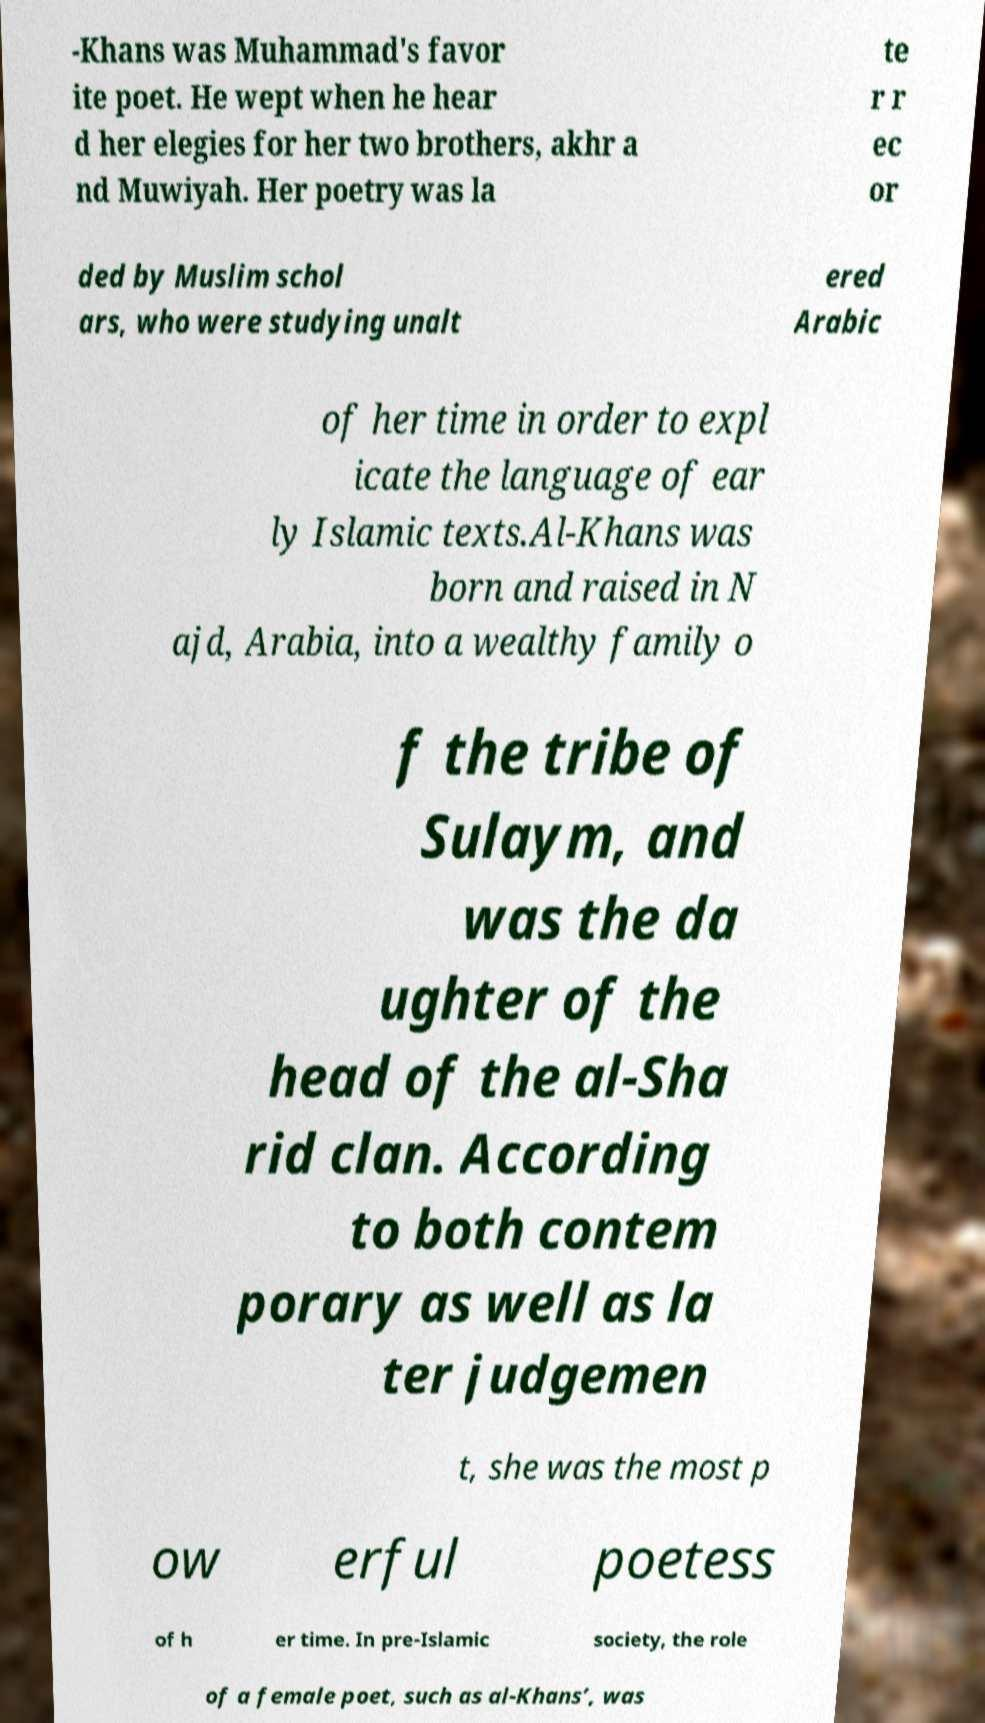Please identify and transcribe the text found in this image. -Khans was Muhammad's favor ite poet. He wept when he hear d her elegies for her two brothers, akhr a nd Muwiyah. Her poetry was la te r r ec or ded by Muslim schol ars, who were studying unalt ered Arabic of her time in order to expl icate the language of ear ly Islamic texts.Al-Khans was born and raised in N ajd, Arabia, into a wealthy family o f the tribe of Sulaym, and was the da ughter of the head of the al-Sha rid clan. According to both contem porary as well as la ter judgemen t, she was the most p ow erful poetess of h er time. In pre-Islamic society, the role of a female poet, such as al-Khans’, was 